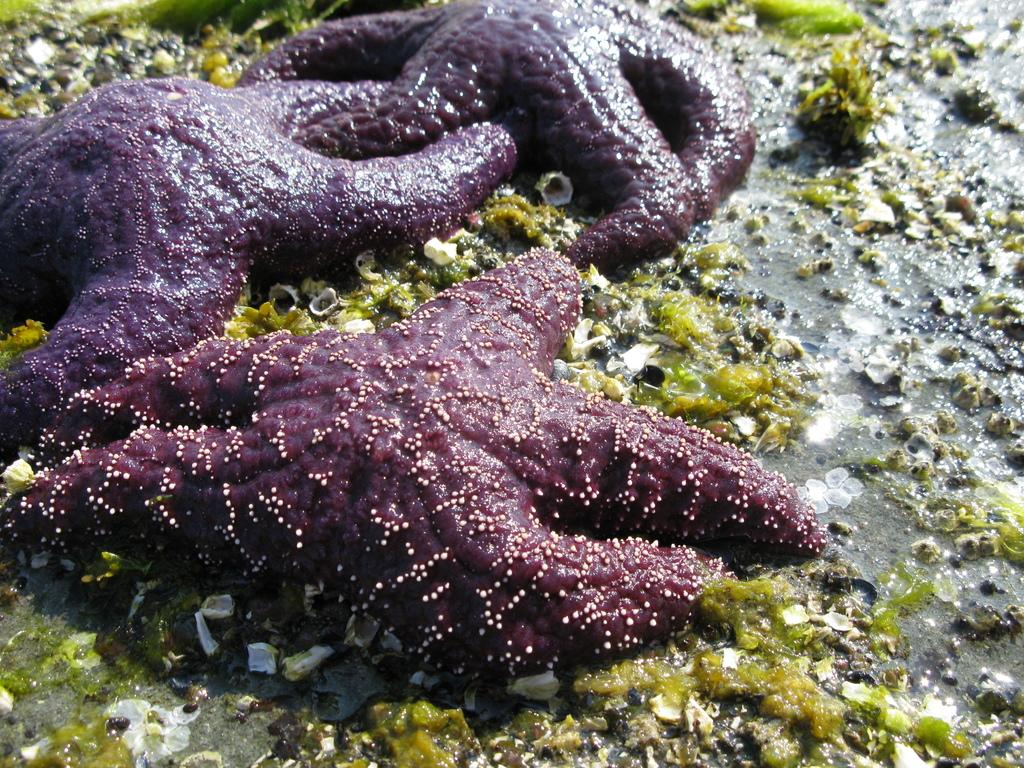What type of sea creatures are in the image? There are starfishes in the image. What color are the starfishes? The starfishes are in maroon color. Where are the starfishes located in the image? The starfishes are on the land. What else can be seen on the land in the image? There is marine debris on the land in the image. How many potatoes are being sliced by the cub in the image? There are no potatoes or cubs present in the image; it features starfishes on the land. How many pizzas are being served by the starfishes in the image? There are no pizzas or serving activities depicted in the image; it only shows starfishes on the land. 